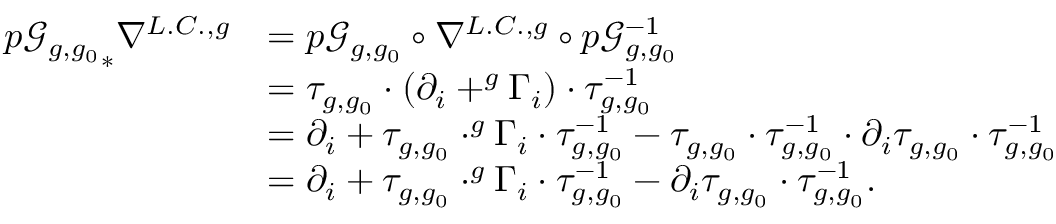Convert formula to latex. <formula><loc_0><loc_0><loc_500><loc_500>\begin{array} { r l } { { p \mathcal { G } _ { g , g _ { 0 } } } _ { \ast } \nabla ^ { L . C . , g } } & { = p \mathcal { G } _ { g , g _ { 0 } } \circ \nabla ^ { L . C . , g } \circ p \mathcal { G } _ { g , g _ { 0 } } ^ { - 1 } } \\ & { = \tau _ { g , g _ { 0 } } \cdot ( \partial _ { i } + ^ { g } \Gamma _ { i } ) \cdot \tau _ { g , g _ { 0 } } ^ { - 1 } } \\ & { = \partial _ { i } + \tau _ { g , g _ { 0 } } \cdot ^ { g } \Gamma _ { i } \cdot \tau _ { g , g _ { 0 } } ^ { - 1 } - \tau _ { g , g _ { 0 } } \cdot \tau _ { g , g _ { 0 } } ^ { - 1 } \cdot \partial _ { i } \tau _ { g , g _ { 0 } } \cdot \tau _ { g , g _ { 0 } } ^ { - 1 } } \\ & { = \partial _ { i } + \tau _ { g , g _ { 0 } } \cdot ^ { g } \Gamma _ { i } \cdot \tau _ { g , g _ { 0 } } ^ { - 1 } - \partial _ { i } \tau _ { g , g _ { 0 } } \cdot \tau _ { g , g _ { 0 } } ^ { - 1 } . } \end{array}</formula> 